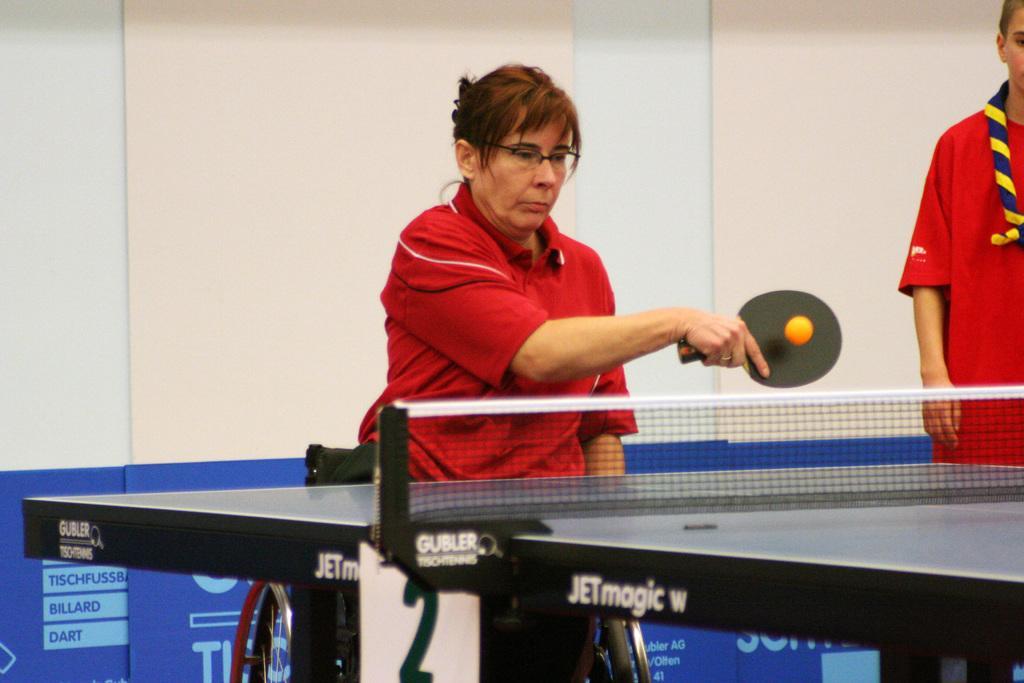Can you describe this image briefly? This woman wore a red t-shirt, sitting on a wheelchair and holding a bat. Ball is in the air. In-front of this woman there is a table tennis table with mesh. Right side of the image we can see another woman is standing and wore red t-shirt. Background there is a wall and hoarding. 